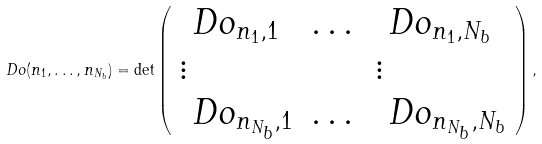Convert formula to latex. <formula><loc_0><loc_0><loc_500><loc_500>\ D o ( n _ { 1 } , \dots , n _ { N _ { b } } ) = \det \left ( \begin{array} { l l l } \ D o _ { n _ { 1 } , 1 } & \dots & \ D o _ { n _ { 1 } , N _ { b } } \\ \vdots & & \vdots \\ \ D o _ { n _ { N _ { b } } , 1 } & \dots & \ D o _ { n _ { N _ { b } } , N _ { b } } \end{array} \right ) ,</formula> 